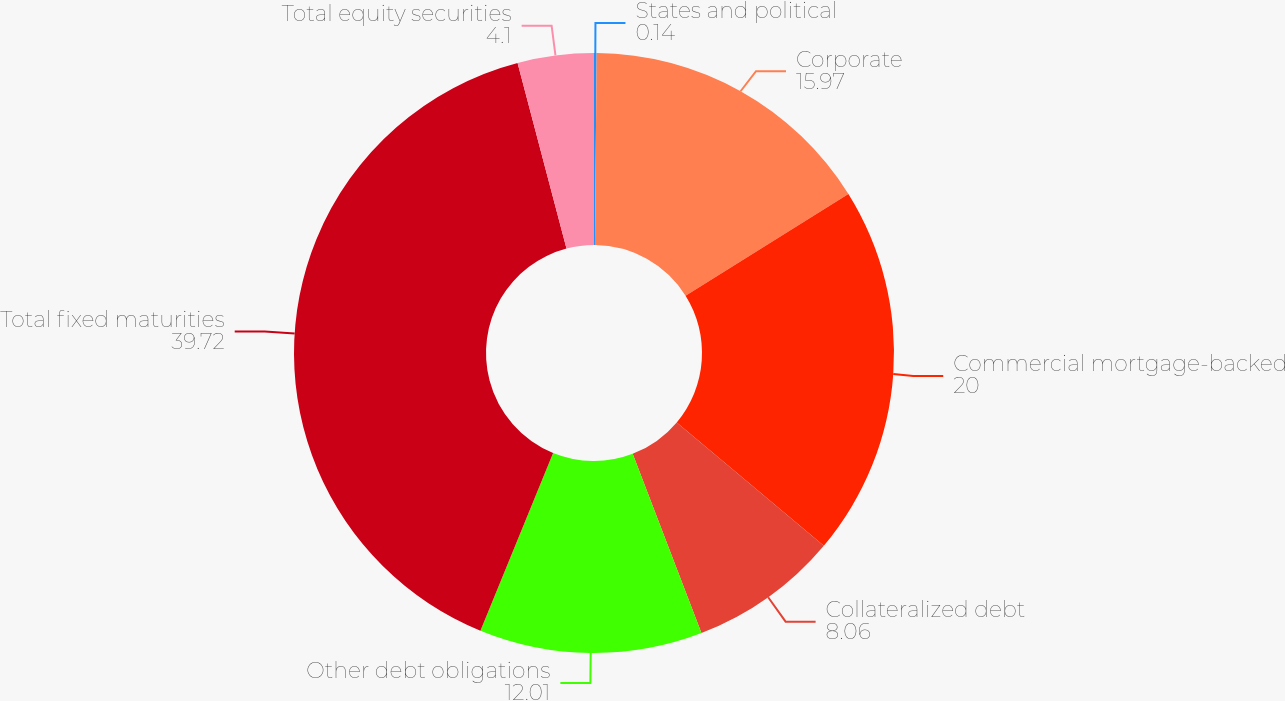Convert chart to OTSL. <chart><loc_0><loc_0><loc_500><loc_500><pie_chart><fcel>States and political<fcel>Corporate<fcel>Commercial mortgage-backed<fcel>Collateralized debt<fcel>Other debt obligations<fcel>Total fixed maturities<fcel>Total equity securities<nl><fcel>0.14%<fcel>15.97%<fcel>20.0%<fcel>8.06%<fcel>12.01%<fcel>39.72%<fcel>4.1%<nl></chart> 